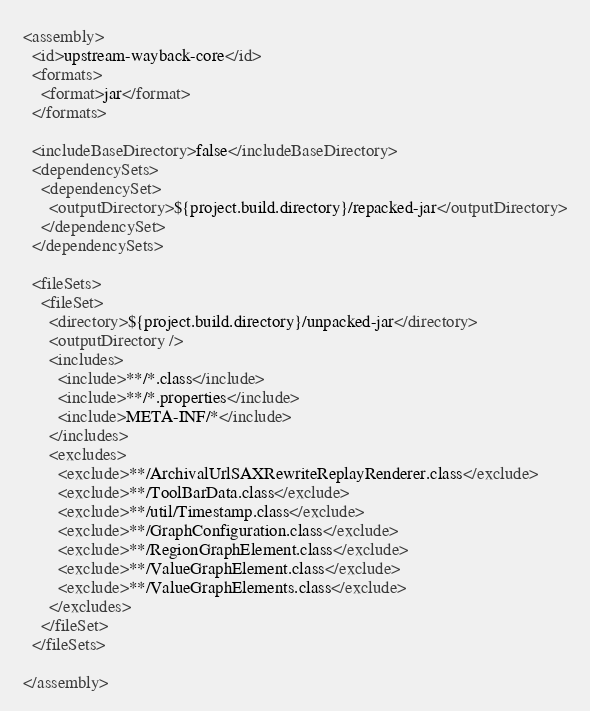<code> <loc_0><loc_0><loc_500><loc_500><_XML_><assembly>
  <id>upstream-wayback-core</id>
  <formats>
    <format>jar</format>
  </formats>

  <includeBaseDirectory>false</includeBaseDirectory>
  <dependencySets>
    <dependencySet>
      <outputDirectory>${project.build.directory}/repacked-jar</outputDirectory>
    </dependencySet>
  </dependencySets>

  <fileSets>
    <fileSet>
      <directory>${project.build.directory}/unpacked-jar</directory>
      <outputDirectory />
      <includes>
        <include>**/*.class</include>
        <include>**/*.properties</include>
        <include>META-INF/*</include>
      </includes>
      <excludes>
        <exclude>**/ArchivalUrlSAXRewriteReplayRenderer.class</exclude>
        <exclude>**/ToolBarData.class</exclude>
        <exclude>**/util/Timestamp.class</exclude>
        <exclude>**/GraphConfiguration.class</exclude>
        <exclude>**/RegionGraphElement.class</exclude>
        <exclude>**/ValueGraphElement.class</exclude>
        <exclude>**/ValueGraphElements.class</exclude>
      </excludes>
    </fileSet>
  </fileSets>

</assembly>
</code> 